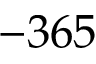Convert formula to latex. <formula><loc_0><loc_0><loc_500><loc_500>- 3 6 5</formula> 